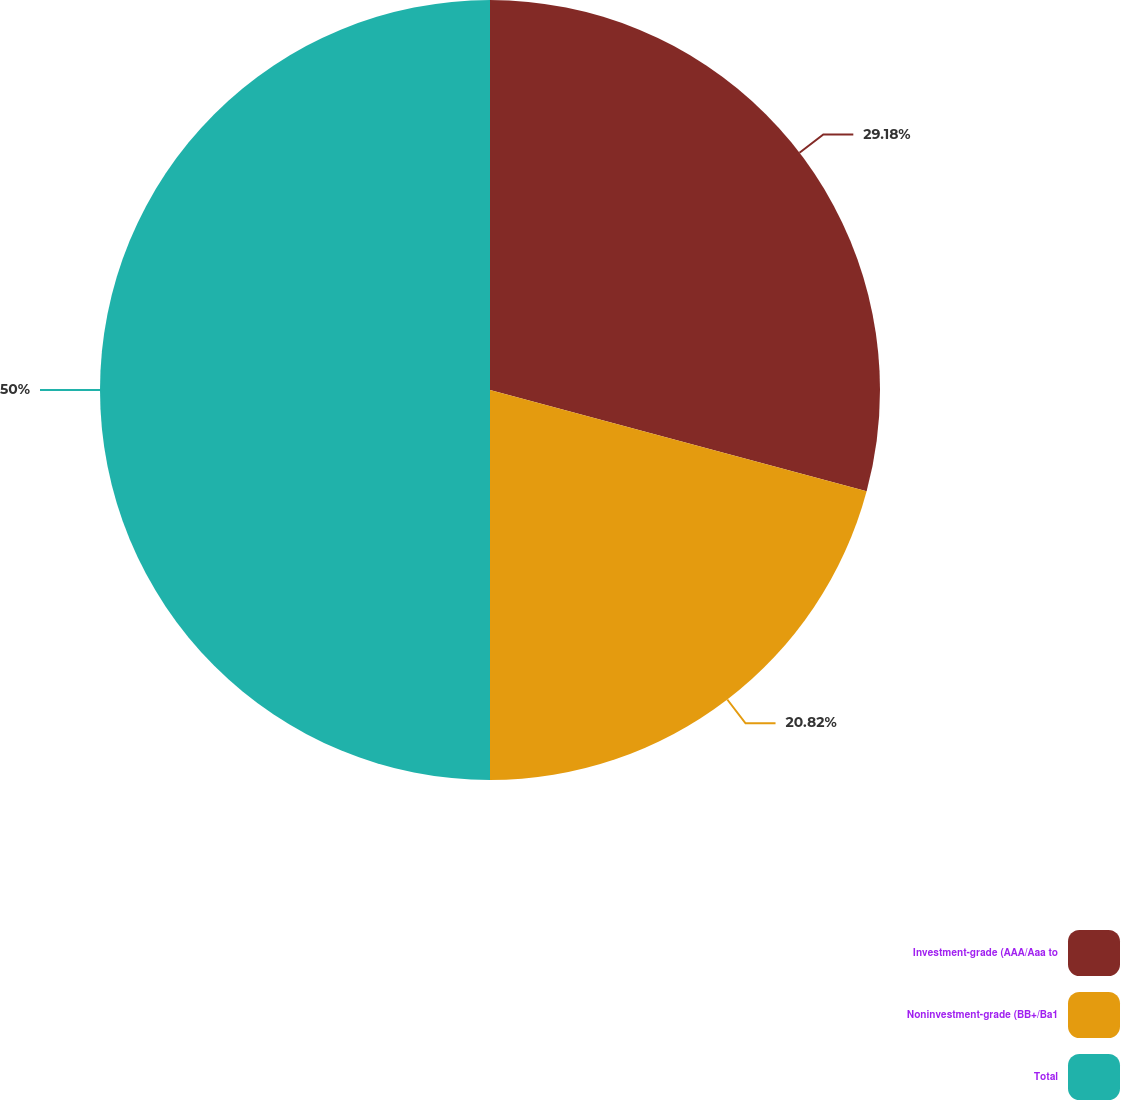Convert chart to OTSL. <chart><loc_0><loc_0><loc_500><loc_500><pie_chart><fcel>Investment-grade (AAA/Aaa to<fcel>Noninvestment-grade (BB+/Ba1<fcel>Total<nl><fcel>29.18%<fcel>20.82%<fcel>50.0%<nl></chart> 